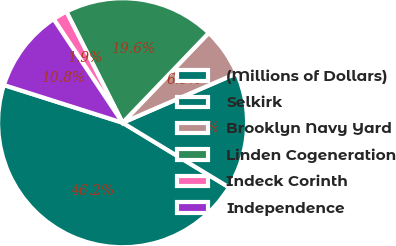<chart> <loc_0><loc_0><loc_500><loc_500><pie_chart><fcel>(Millions of Dollars)<fcel>Selkirk<fcel>Brooklyn Navy Yard<fcel>Linden Cogeneration<fcel>Indeck Corinth<fcel>Independence<nl><fcel>46.21%<fcel>15.19%<fcel>6.33%<fcel>19.62%<fcel>1.89%<fcel>10.76%<nl></chart> 